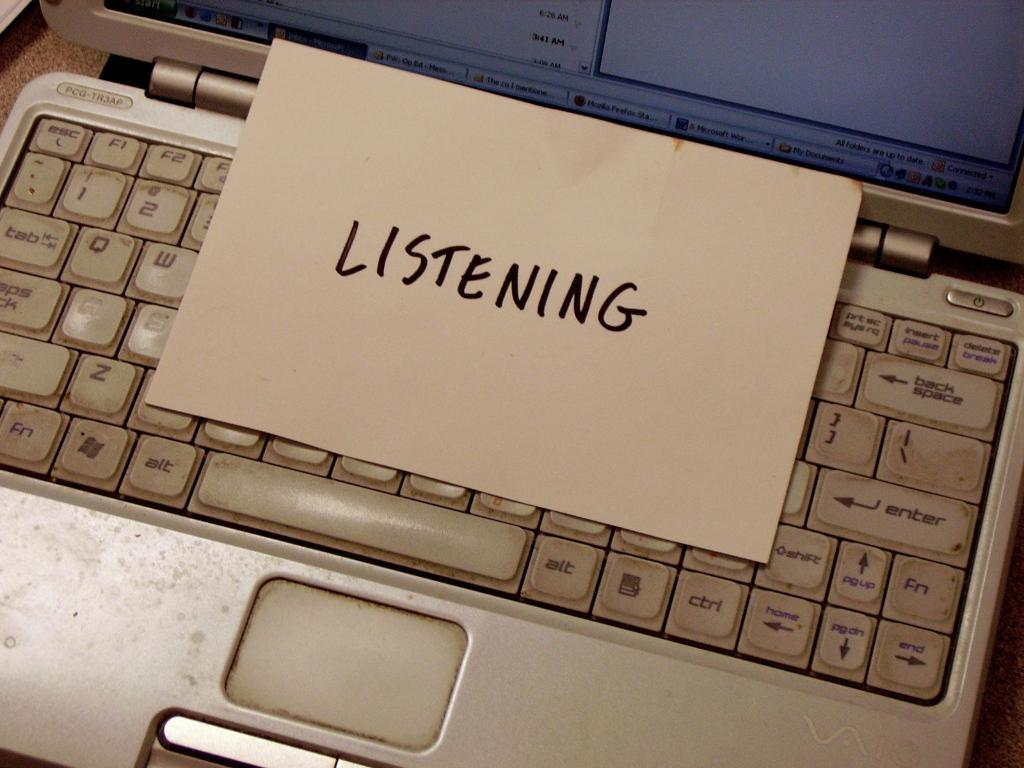<image>
Write a terse but informative summary of the picture. Piece of paper that says "Listening" on top of a white laptop. 